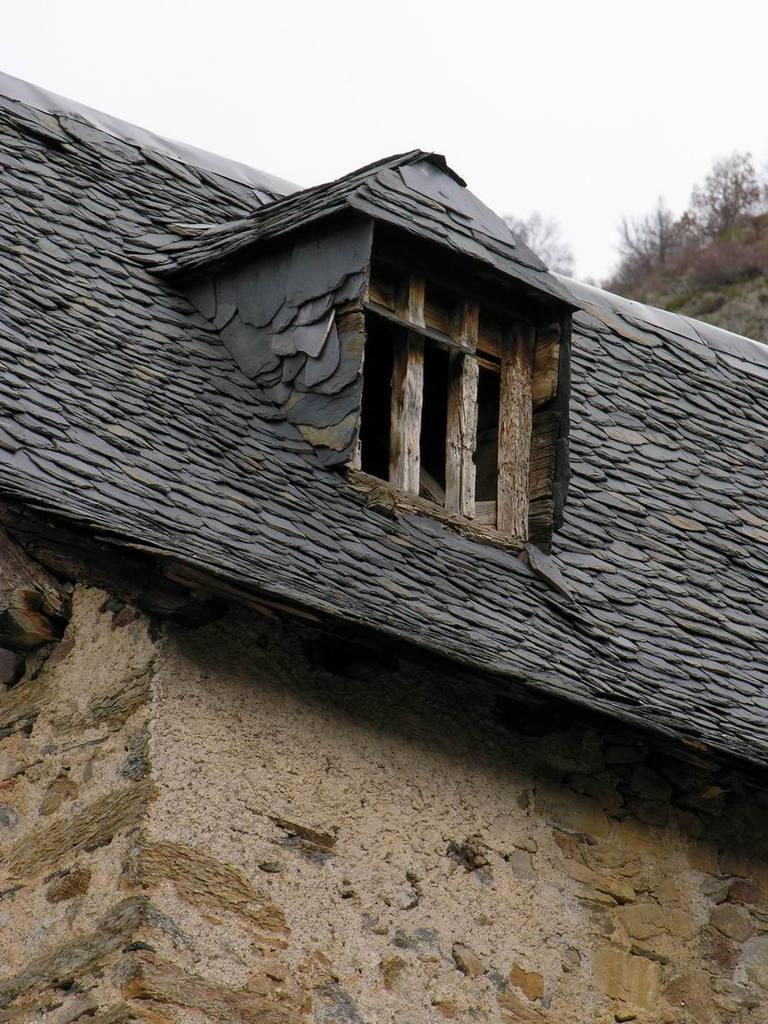What type of structure is visible in the image? There is a wall and a roof in the image, suggesting a building or house. Can you describe any openings in the structure? Yes, there is a window in the image. What can be seen in the background of the image? There are trees and the sky visible in the background of the image. What type of light is being used to illuminate the hospital in the image? There is no hospital present in the image, and therefore no light being used to illuminate it. 